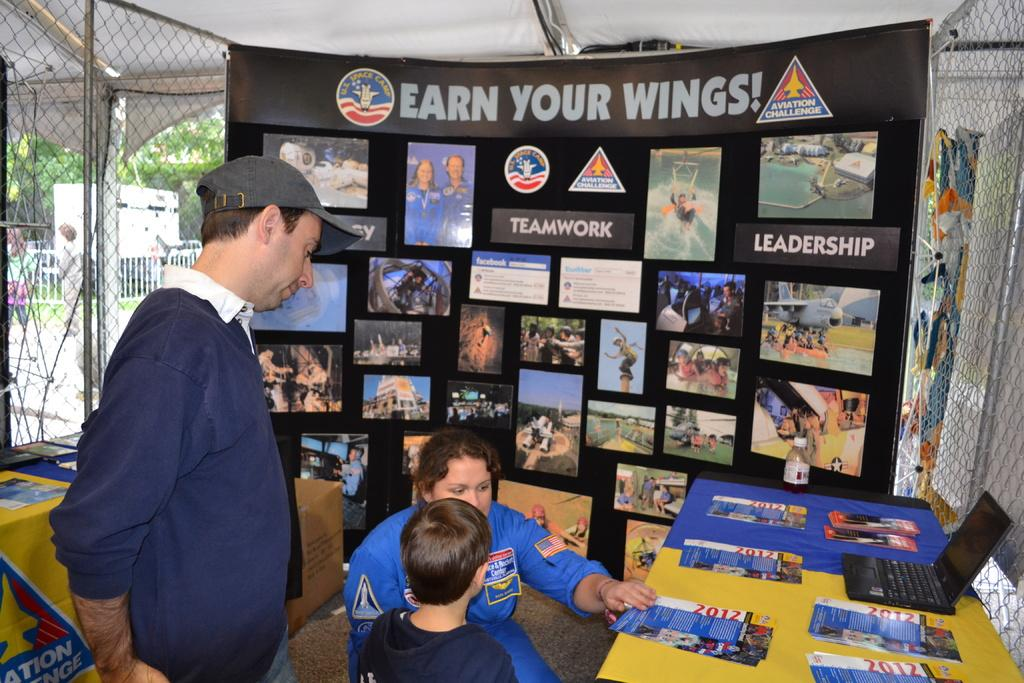What is the main focus of the image? The main focus of the image is the people in the center. What objects are on the table in the image? There are papers and a laptop on the table in the image. What can be seen in the background of the image? There is a mesh and a banner in the background of the image. What type of pain medication is being administered to the trees in the image? There are no trees or any reference to pain medication in the image. 